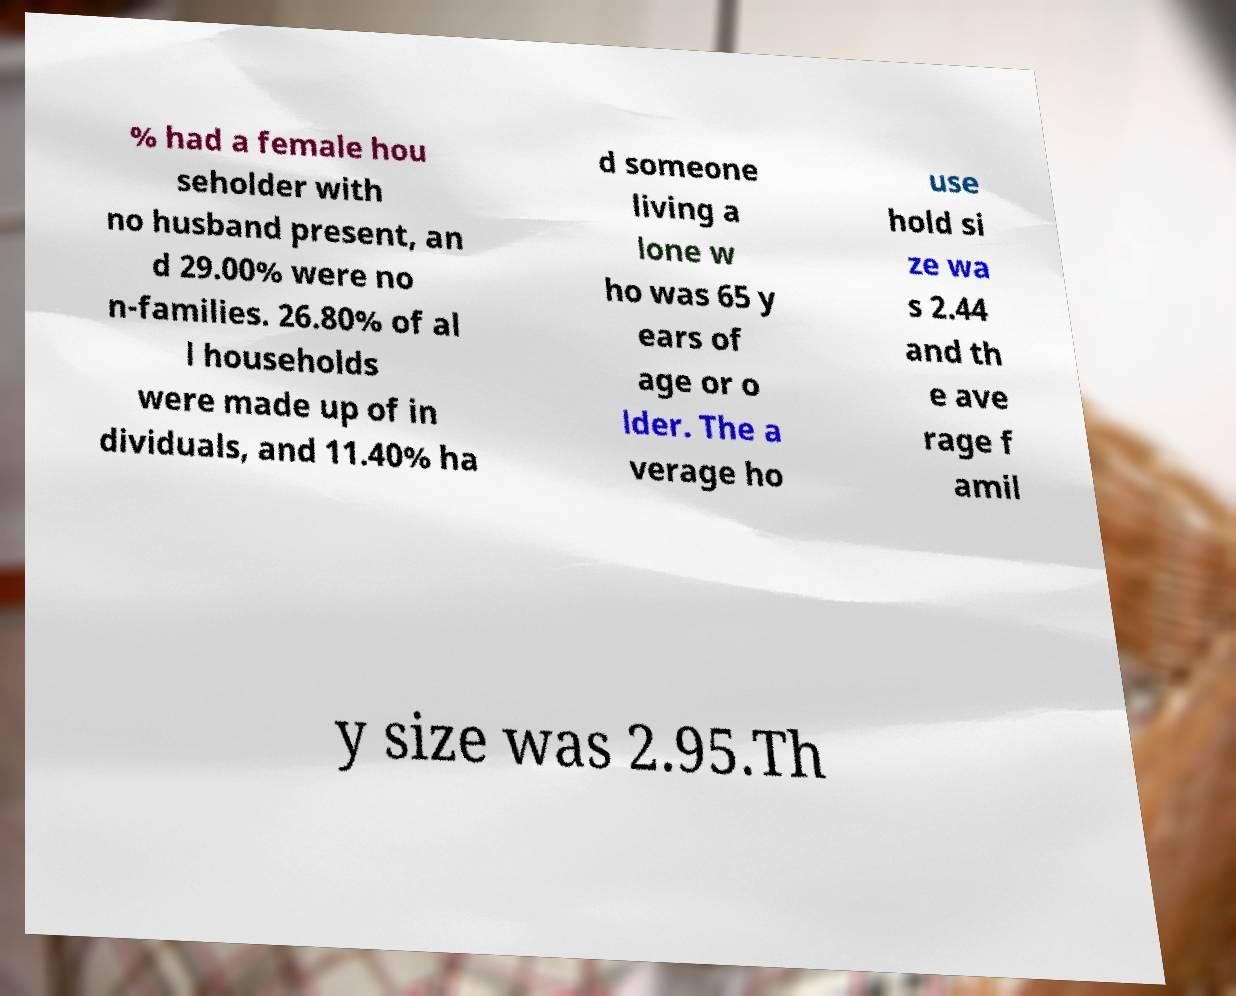I need the written content from this picture converted into text. Can you do that? % had a female hou seholder with no husband present, an d 29.00% were no n-families. 26.80% of al l households were made up of in dividuals, and 11.40% ha d someone living a lone w ho was 65 y ears of age or o lder. The a verage ho use hold si ze wa s 2.44 and th e ave rage f amil y size was 2.95.Th 